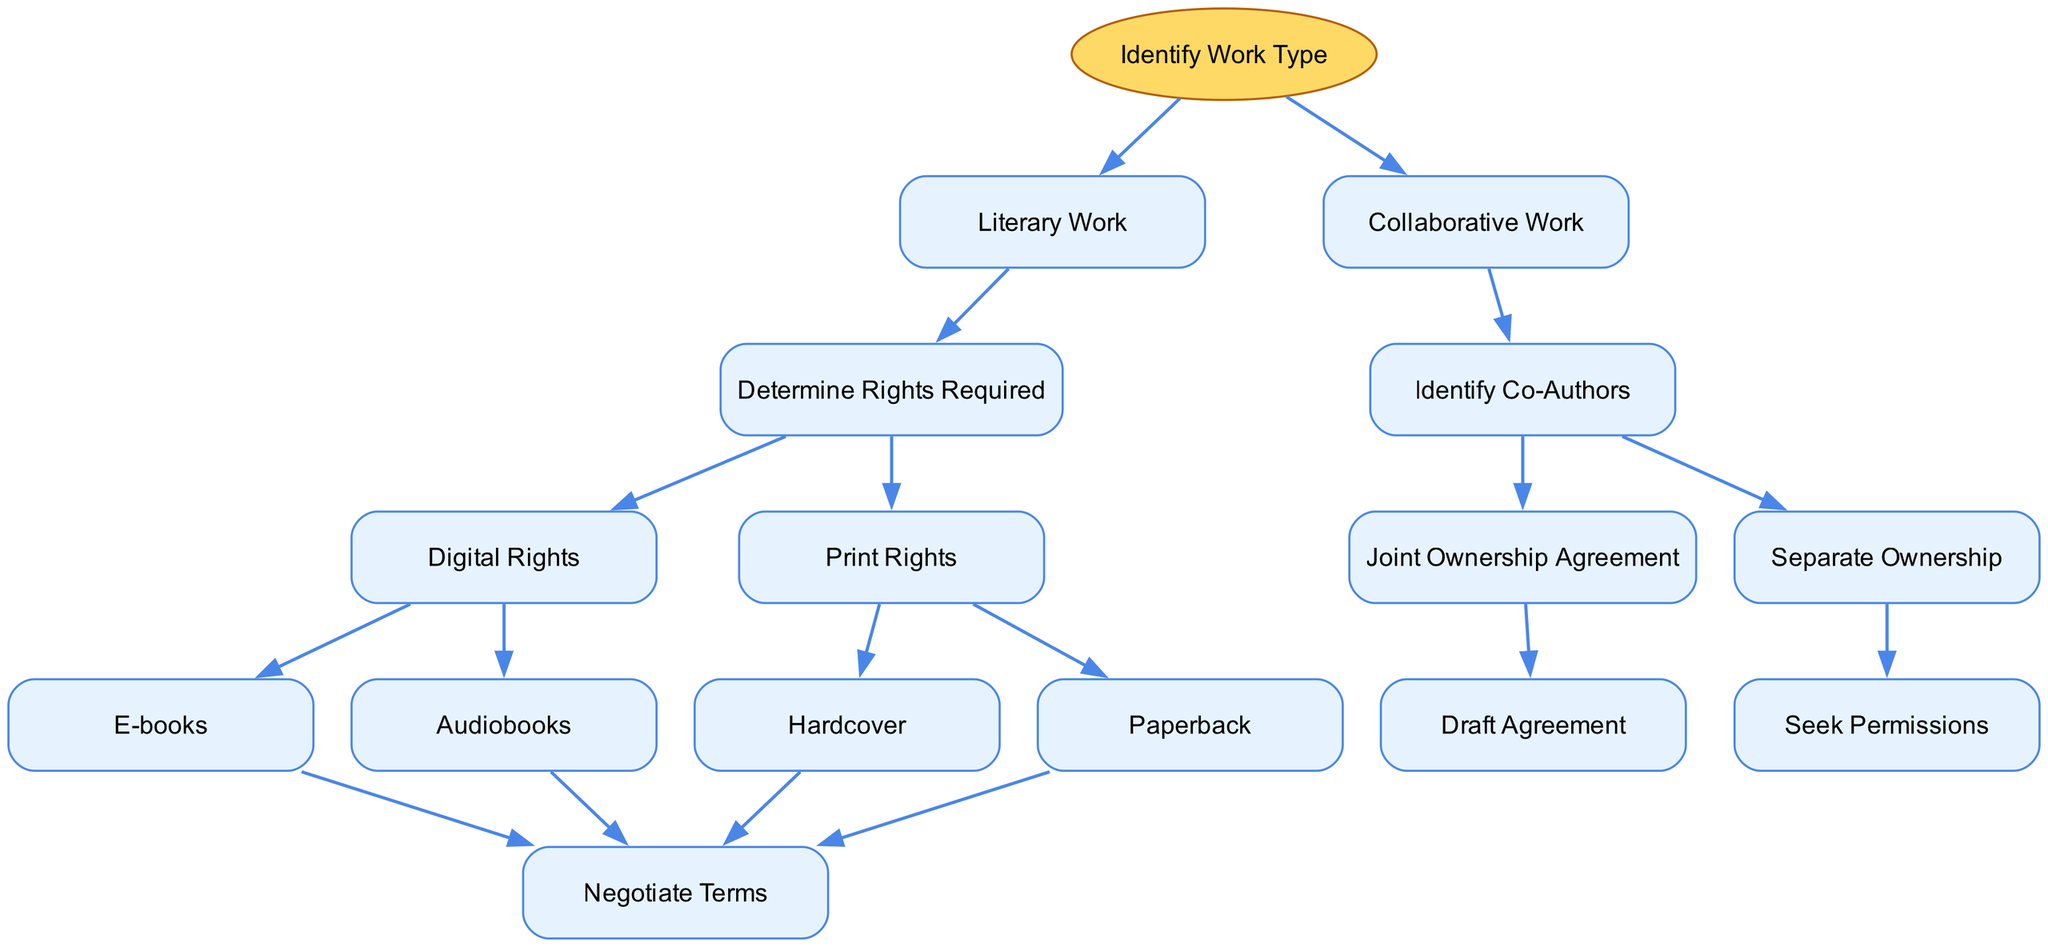What is the starting point of the diagram? The diagram begins with the node labeled "Identify Work Type," which serves as the initial step in the rights management process.
Answer: Identify Work Type How many main branches are present in the diagram? There are two main branches stemming from the "Identify Work Type" node: "Literary Work" and "Collaborative Work." Therefore, the count is 2.
Answer: 2 What rights are determined after identifying a "Literary Work"? Following "Literary Work," the next step is to "Determine Rights Required," focusing specifically on the rights needed for the literary work.
Answer: Determine Rights Required What are the two types of digital rights listed under "Determine Rights Required"? Under "Determine Rights Required," the diagram specifies "Digital Rights," which are divided into "E-books" and "Audiobooks" as the two primary types.
Answer: E-books, Audiobooks What do you do after identifying co-authors in a "Collaborative Work"? After identifying co-authors, the next step is to decide between two options: a "Joint Ownership Agreement" or "Separate Ownership," leading to different actions.
Answer: Draft Agreement or Seek Permissions Which node leads to negotiating terms for an "Audiobook"? The path towards negotiating terms for an "Audiobook" begins at the "Digital Rights" node, which subsequently branches to "Audiobooks" before leading to "Negotiate Terms."
Answer: Negotiate Terms How does the decision tree differentiate between ownership types in collaborative work? The decision tree differentiates between ownership types after identifying co-authors by presenting two paths: a "Joint Ownership Agreement" resulting in drafting the agreement, or "Separate Ownership," which requires seeking permissions.
Answer: Joint Ownership Agreement or Separate Ownership What is the next step after selecting "Print Rights"? After selecting "Print Rights," the flow of the diagram moves to two types of printing options: "Hardcover" and "Paperback," both of which subsequently lead to "Negotiate Terms."
Answer: Negotiate Terms What type of work does the node "Joint Ownership Agreement" correspond to? The node "Joint Ownership Agreement" specifically corresponds to the branch concerning "Collaborative Work," indicating a shared rights structure among authors.
Answer: Collaborative Work 